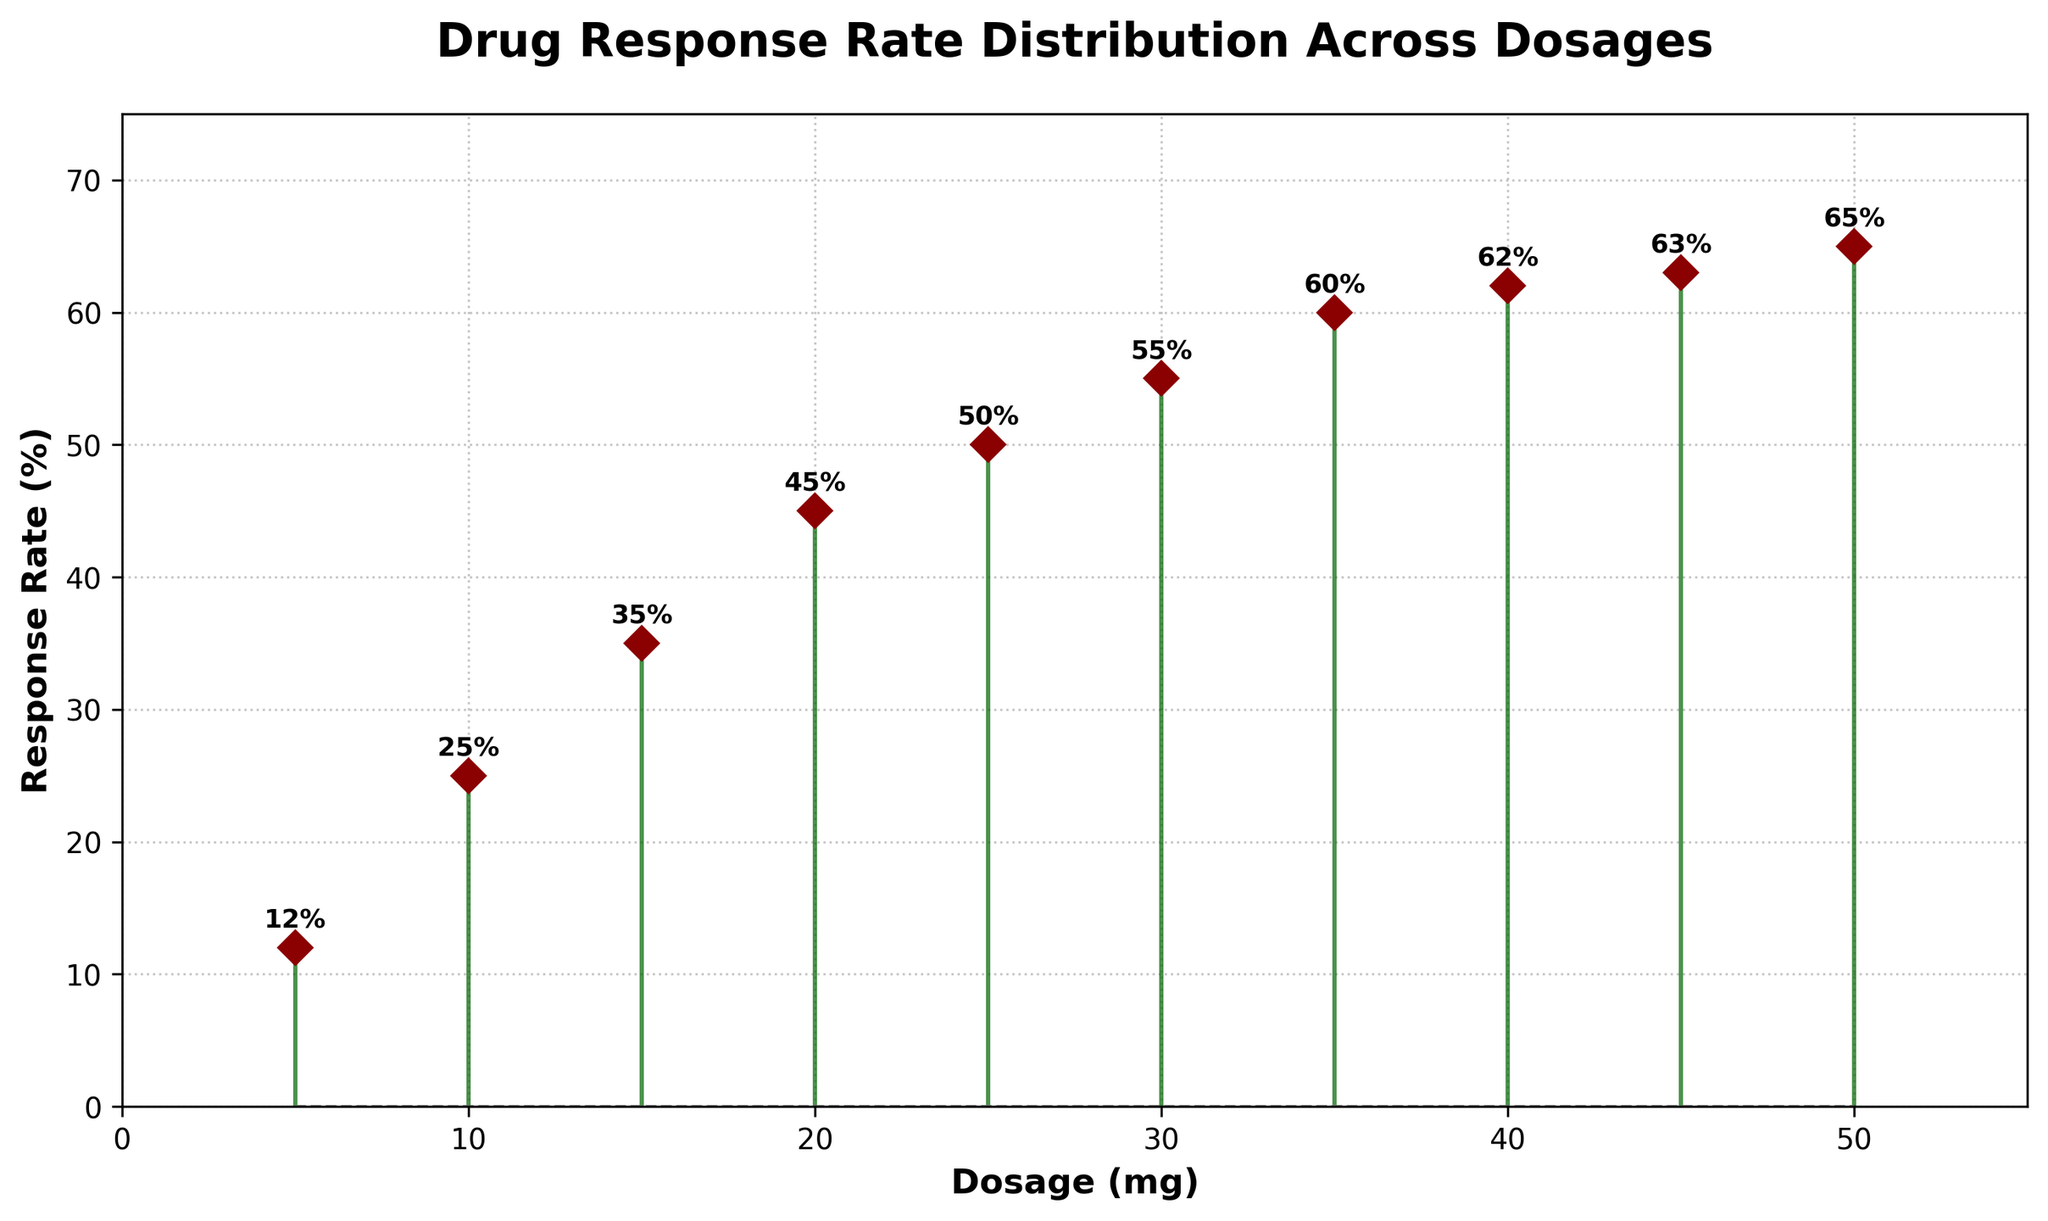How many different dosages are represented in the figure? Count the number of distinct data points on the x-axis. There are data points for each dosage value from 5 mg to 50 mg, with a consistent step of 5 mg between them.
Answer: 10 What is the response rate at 25 mg? Locate the dosage value of 25 mg on the x-axis, then identify the corresponding response rate on the y-axis. It is annotated beside the data point.
Answer: 50% What dosage yields the highest response rate? Look for the data point with the highest y-axis value. The highest response rate is 65%, corresponding to 50 mg.
Answer: 50 mg How does the response rate change between 10 mg and 20 mg? Compare the response rates at these two dosages. At 10 mg, the response rate is 25%; at 20 mg, it is 45%. The difference is 45% - 25% = 20%.
Answer: It increases by 20% What is the average response rate for all dosages shown? Sum all the response rates provided (12 + 25 + 35 + 45 + 50 + 55 + 60 + 62 + 63 + 65) and divide by the number of dosages, which is 10. The calculation is (12+25+35+45+50+55+60+62+63+65)/10 = 47.2%.
Answer: 47.2% Which dosage has the smallest increase in response rate compared to the next dosage? Calculate the differences between successive dosages and look for the smallest increase. Here, the increase is smallest between 40 mg and 45 mg where the response rate increases by 1% (63% - 62%).
Answer: Between 40 mg and 45 mg Is there any dosage at which the response rate does not increase from the previous dosage? Examine the change in response rates between consecutive dosages. Every next higher dosage sees an increased response rate; there is no instance where it stays the same or decreases.
Answer: No What is the trend in response rate as dosage increases? Observe the overall pattern in the figure. The response rate generally increases with increasing dosage, forming a roughly upward trend.
Answer: Increasing What's the total response rate when combining those from 15 mg, 25 mg, and 35 mg dosages? Add the response rates for these specific dosages: 35% (15 mg), 50% (25 mg), and 60% (35 mg). The sum is 35 + 50 + 60 = 145%.
Answer: 145% 